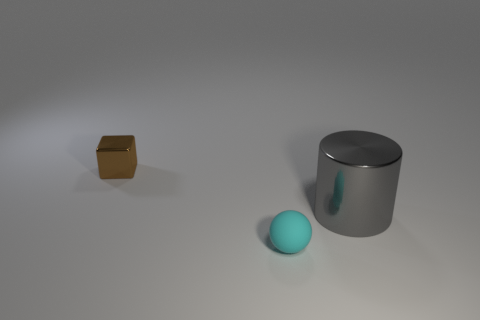Is the size of the metallic thing to the right of the cyan ball the same as the brown object?
Offer a very short reply. No. What number of metallic objects are large gray cylinders or green things?
Your answer should be very brief. 1. There is a thing that is behind the sphere and in front of the metal cube; what material is it made of?
Ensure brevity in your answer.  Metal. Does the ball have the same material as the large gray thing?
Provide a succinct answer. No. What is the size of the object that is both behind the ball and in front of the tiny brown object?
Your answer should be very brief. Large. The gray object is what shape?
Provide a succinct answer. Cylinder. What number of things are either rubber spheres or things that are behind the tiny cyan rubber thing?
Make the answer very short. 3. Do the shiny thing that is to the left of the tiny rubber object and the rubber thing have the same color?
Offer a very short reply. No. What is the color of the thing that is both to the left of the big cylinder and behind the small cyan object?
Offer a very short reply. Brown. There is a small object in front of the big metal cylinder; what is it made of?
Offer a terse response. Rubber. 